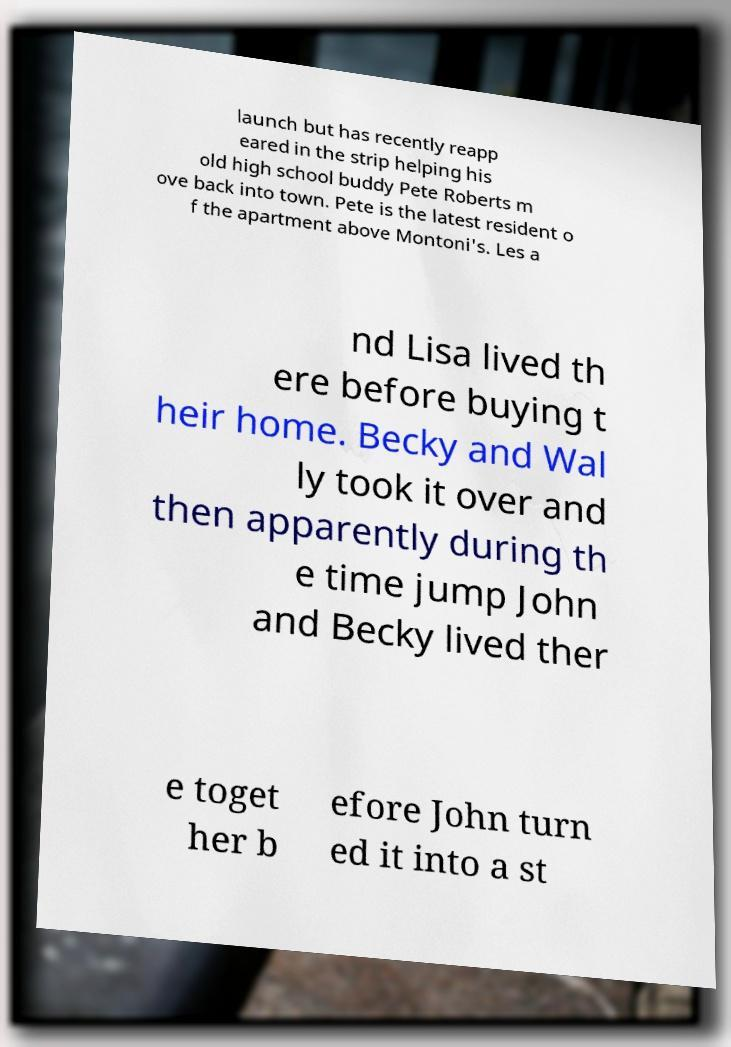There's text embedded in this image that I need extracted. Can you transcribe it verbatim? launch but has recently reapp eared in the strip helping his old high school buddy Pete Roberts m ove back into town. Pete is the latest resident o f the apartment above Montoni's. Les a nd Lisa lived th ere before buying t heir home. Becky and Wal ly took it over and then apparently during th e time jump John and Becky lived ther e toget her b efore John turn ed it into a st 